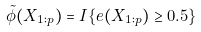<formula> <loc_0><loc_0><loc_500><loc_500>\tilde { \phi } ( X _ { 1 \colon p } ) = I \{ e ( X _ { 1 \colon p } ) \geq 0 . 5 \}</formula> 